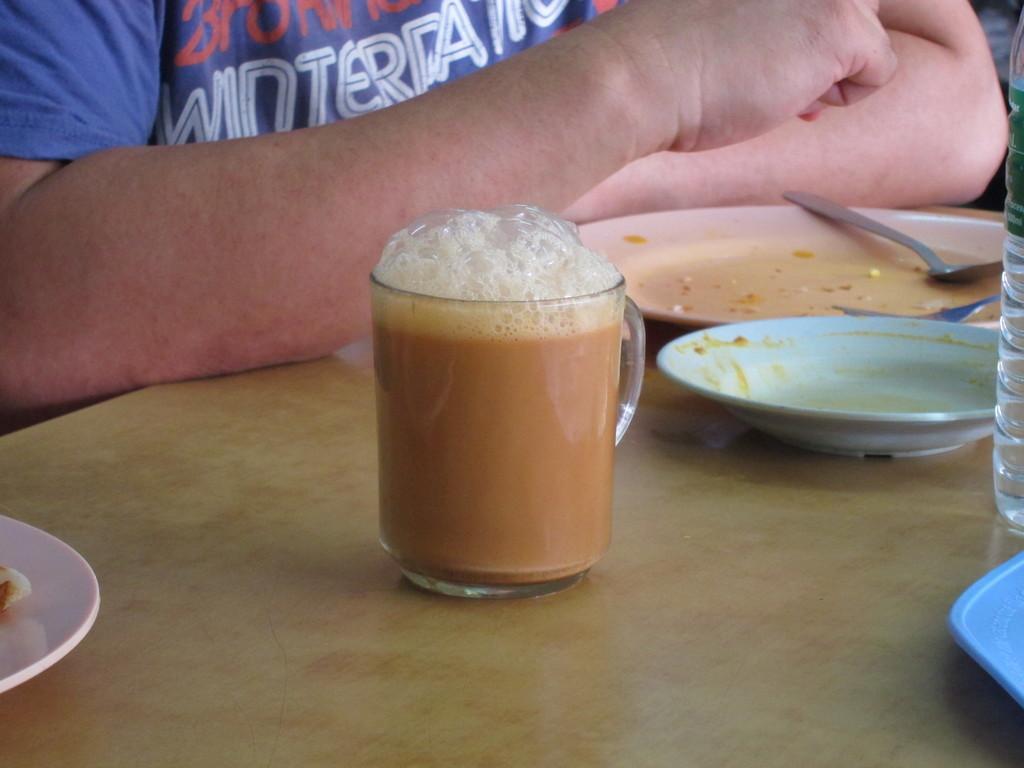In one or two sentences, can you explain what this image depicts? In this image I can see tea in a cup. I can see plates,spoons,bottle on the brown color table. Back I can see a person. 